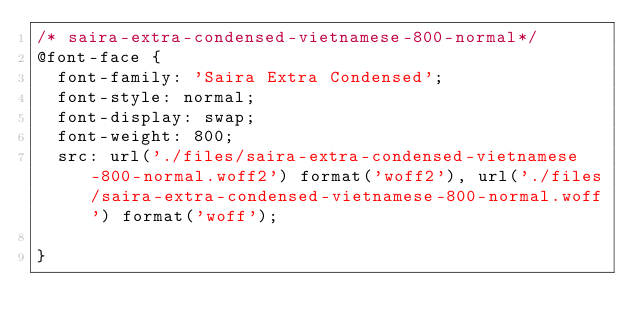Convert code to text. <code><loc_0><loc_0><loc_500><loc_500><_CSS_>/* saira-extra-condensed-vietnamese-800-normal*/
@font-face {
  font-family: 'Saira Extra Condensed';
  font-style: normal;
  font-display: swap;
  font-weight: 800;
  src: url('./files/saira-extra-condensed-vietnamese-800-normal.woff2') format('woff2'), url('./files/saira-extra-condensed-vietnamese-800-normal.woff') format('woff');
  
}
</code> 